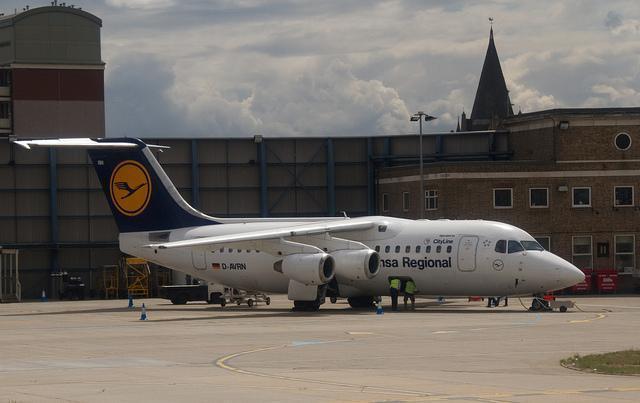How many slices of pizza are there?
Give a very brief answer. 0. 